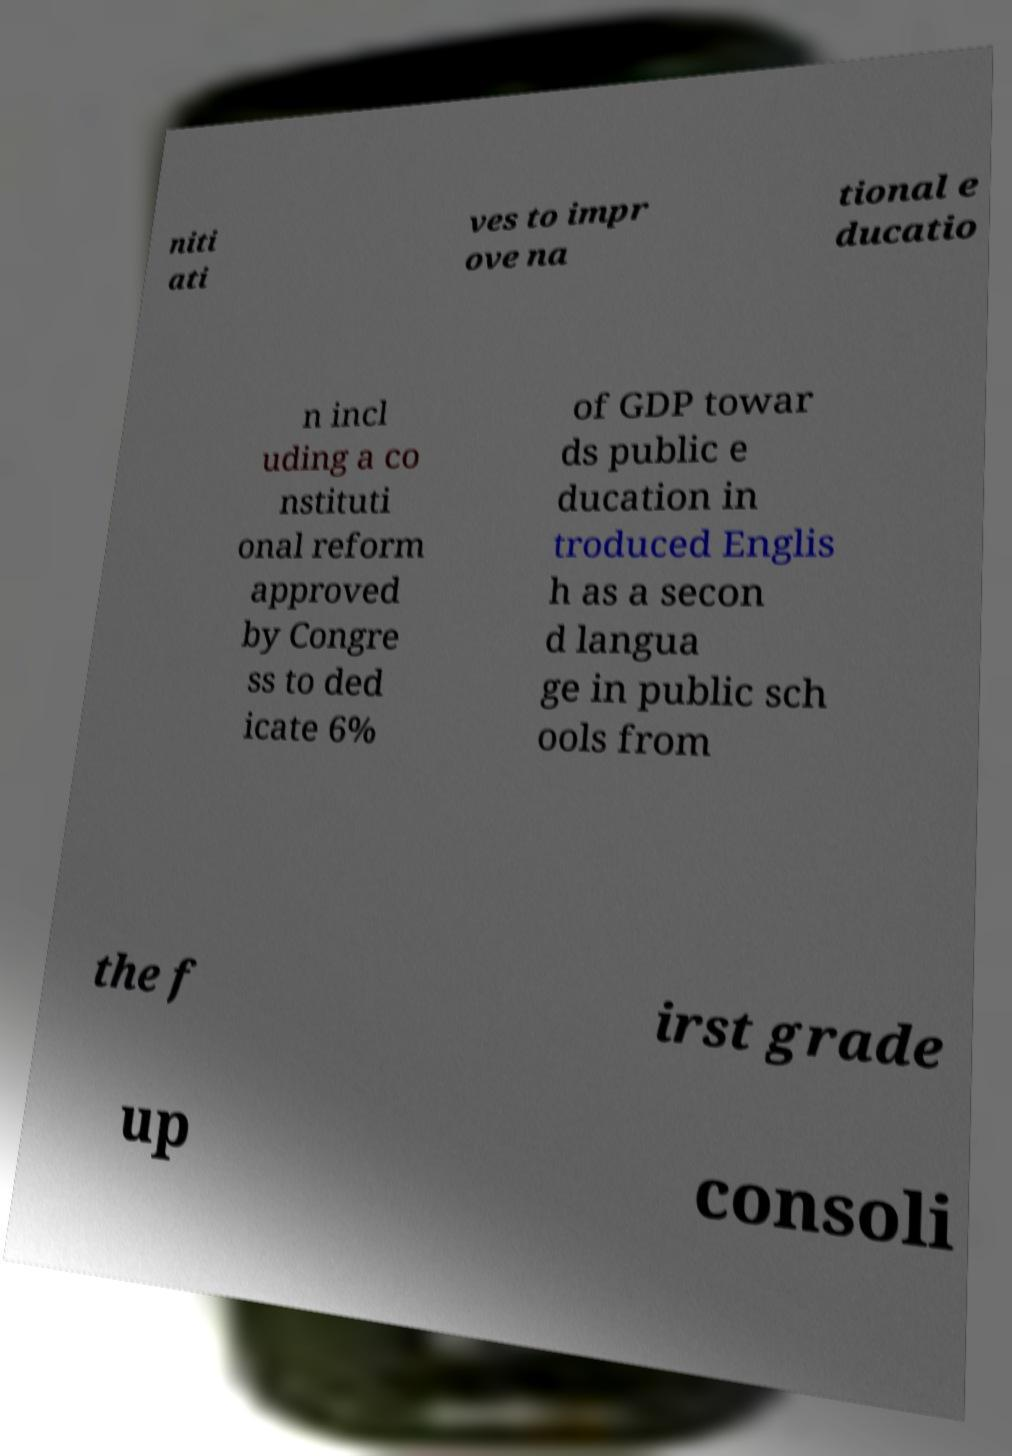Can you read and provide the text displayed in the image?This photo seems to have some interesting text. Can you extract and type it out for me? niti ati ves to impr ove na tional e ducatio n incl uding a co nstituti onal reform approved by Congre ss to ded icate 6% of GDP towar ds public e ducation in troduced Englis h as a secon d langua ge in public sch ools from the f irst grade up consoli 